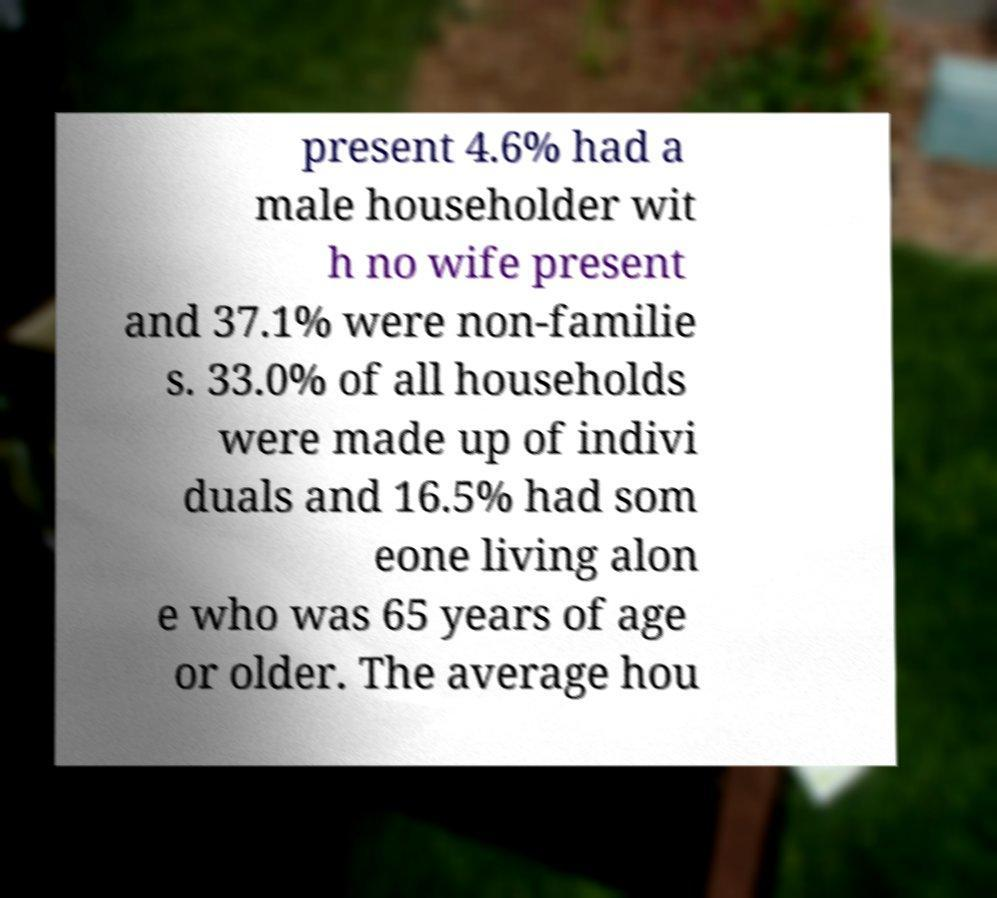Could you assist in decoding the text presented in this image and type it out clearly? present 4.6% had a male householder wit h no wife present and 37.1% were non-familie s. 33.0% of all households were made up of indivi duals and 16.5% had som eone living alon e who was 65 years of age or older. The average hou 